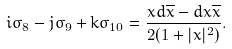<formula> <loc_0><loc_0><loc_500><loc_500>i \sigma _ { 8 } - j \sigma _ { 9 } + k \sigma _ { 1 0 } = \frac { x d \overline { x } - d x \overline { x } } { 2 ( 1 + | x | ^ { 2 } ) } .</formula> 